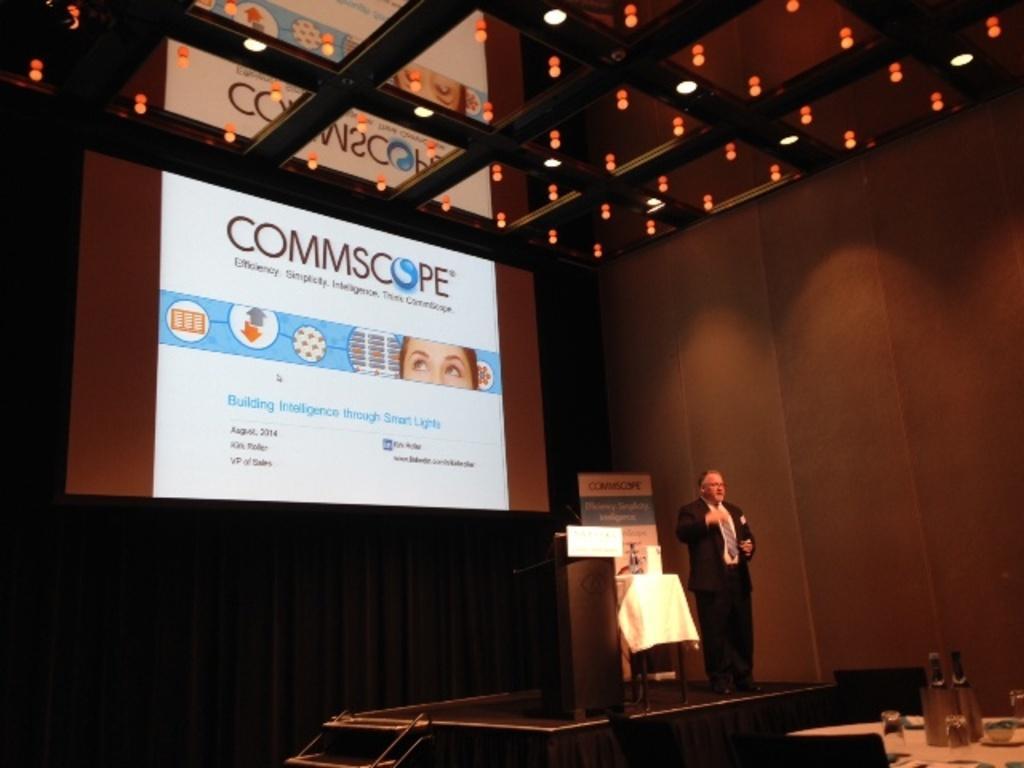Could you give a brief overview of what you see in this image? In this image man is standing on the stage and beside him there is a dais and at the back side there is a projector and in front of him there is a dining table and glasses, bottles were placed on it. 